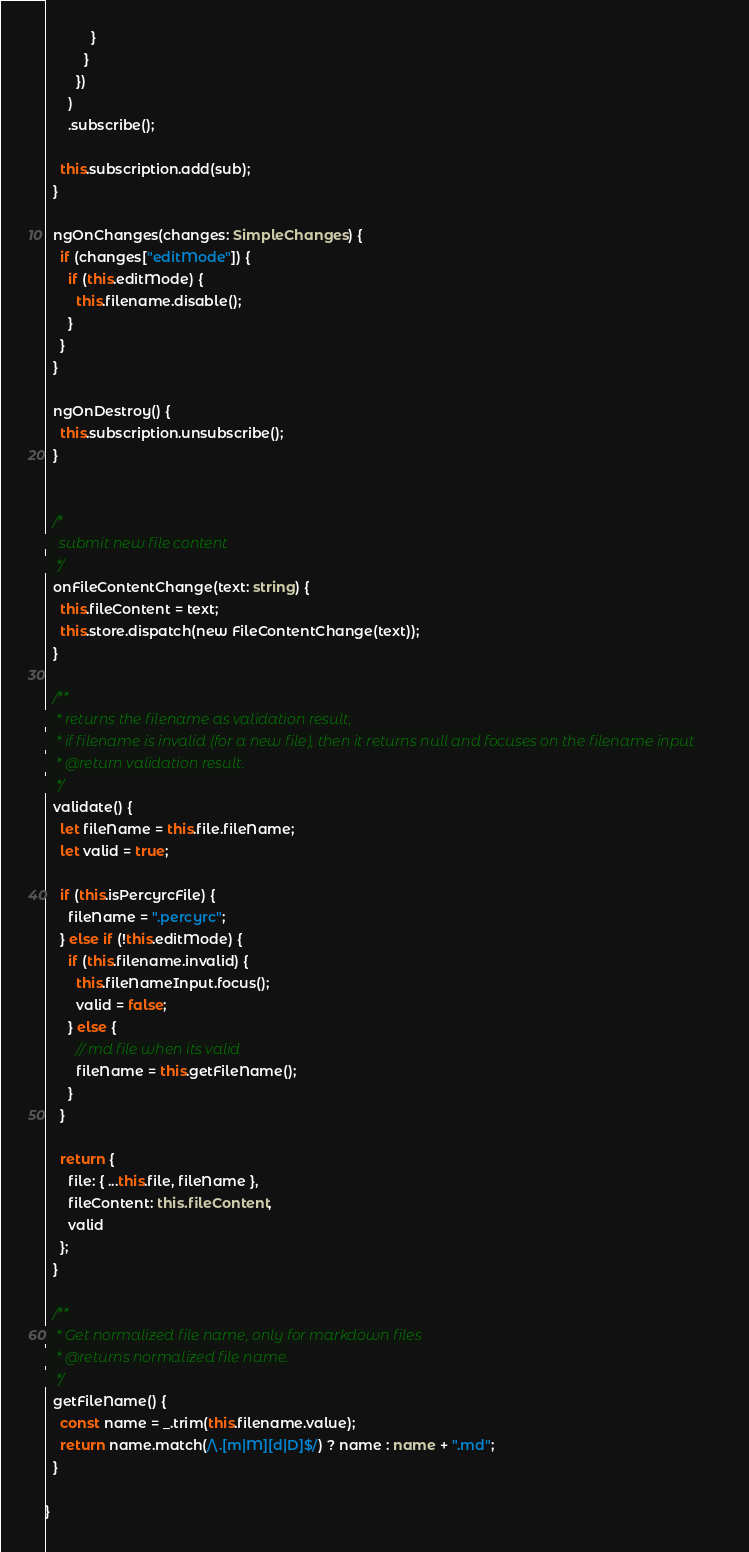<code> <loc_0><loc_0><loc_500><loc_500><_TypeScript_>            }
          }
        })
      )
      .subscribe();

    this.subscription.add(sub);
  }

  ngOnChanges(changes: SimpleChanges) {
    if (changes["editMode"]) {
      if (this.editMode) {
        this.filename.disable();
      }
    }
  }

  ngOnDestroy() {
    this.subscription.unsubscribe();
  }


  /*
    submit new file content
   */
  onFileContentChange(text: string) {
    this.fileContent = text;
    this.store.dispatch(new FileContentChange(text));
  }

  /**
   * returns the filename as validation result,
   * if filename is invalid (for a new file), then it returns null and focuses on the filename input
   * @return validation result.
   */
  validate() {
    let fileName = this.file.fileName;
    let valid = true;

    if (this.isPercyrcFile) {
      fileName = ".percyrc";
    } else if (!this.editMode) {
      if (this.filename.invalid) {
        this.fileNameInput.focus();
        valid = false;
      } else {
        // md file when its valid
        fileName = this.getFileName();
      }
    }

    return {
      file: { ...this.file, fileName },
      fileContent: this.fileContent,
      valid
    };
  }

  /**
   * Get normalized file name, only for markdown files
   * @returns normalized file name.
   */
  getFileName() {
    const name = _.trim(this.filename.value);
    return name.match(/\.[m|M][d|D]$/) ? name : name + ".md";
  }

}
</code> 